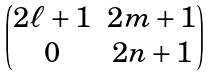<formula> <loc_0><loc_0><loc_500><loc_500>\begin{pmatrix} 2 \ell + 1 & 2 m + 1 \\ 0 & 2 n + 1 \end{pmatrix}</formula> 